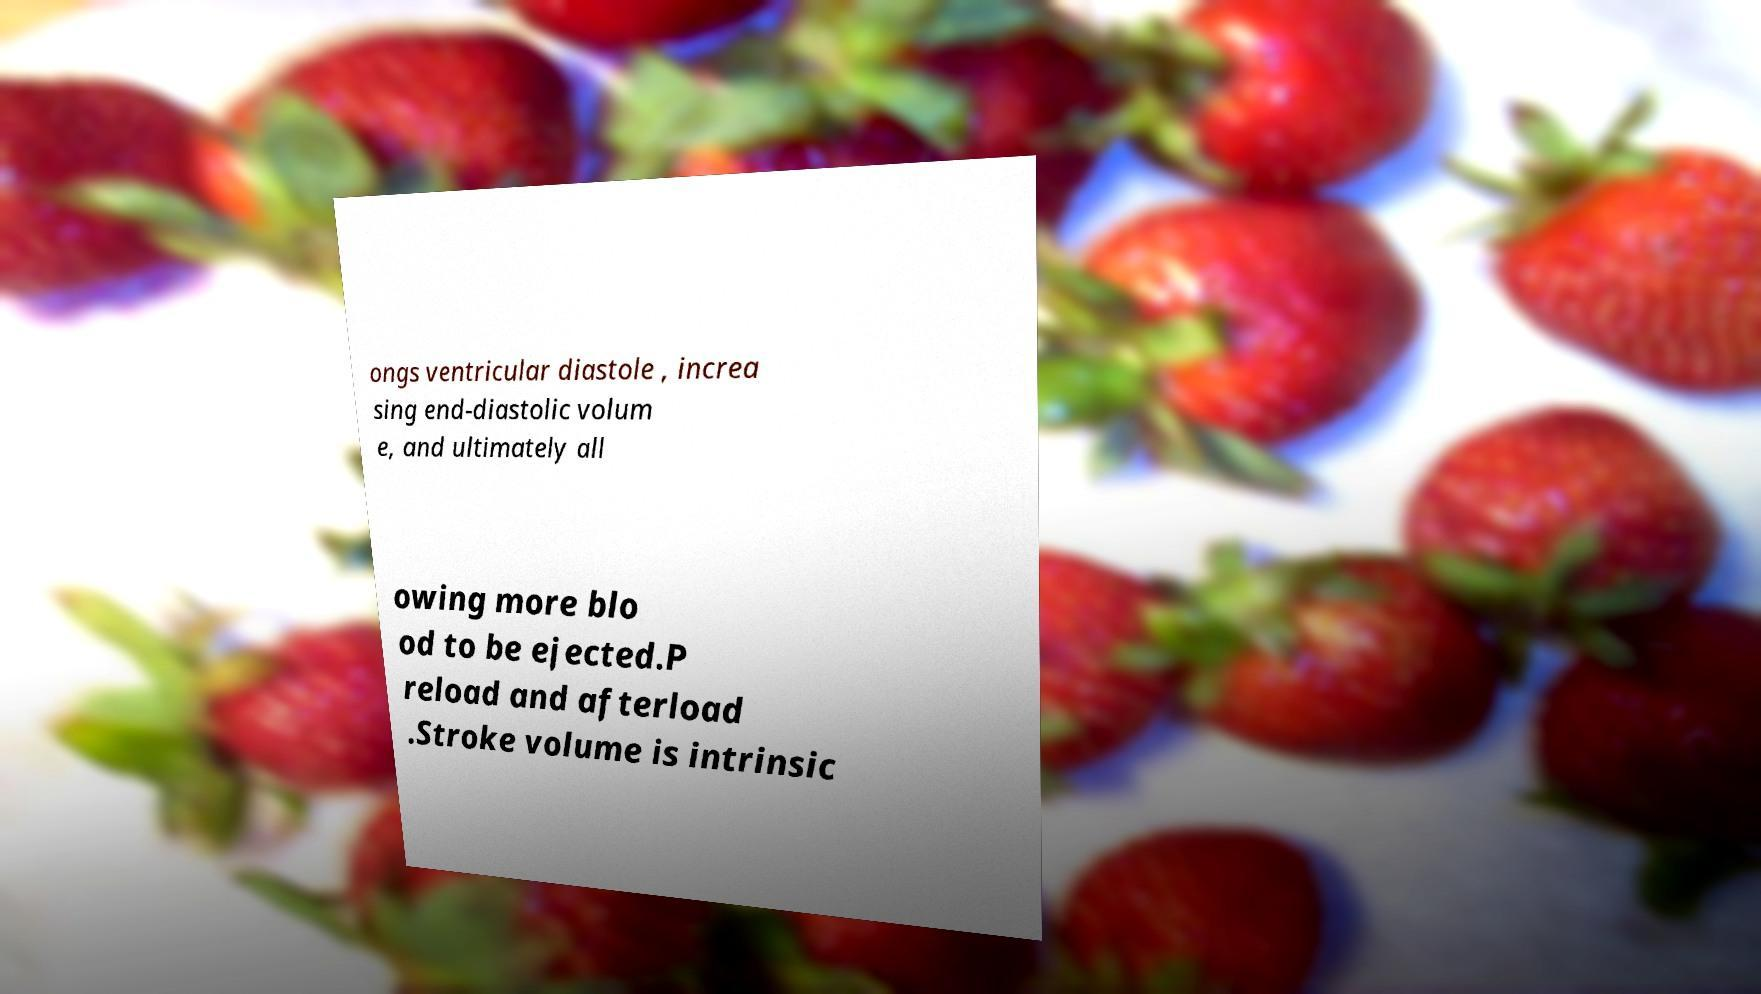Could you extract and type out the text from this image? ongs ventricular diastole , increa sing end-diastolic volum e, and ultimately all owing more blo od to be ejected.P reload and afterload .Stroke volume is intrinsic 